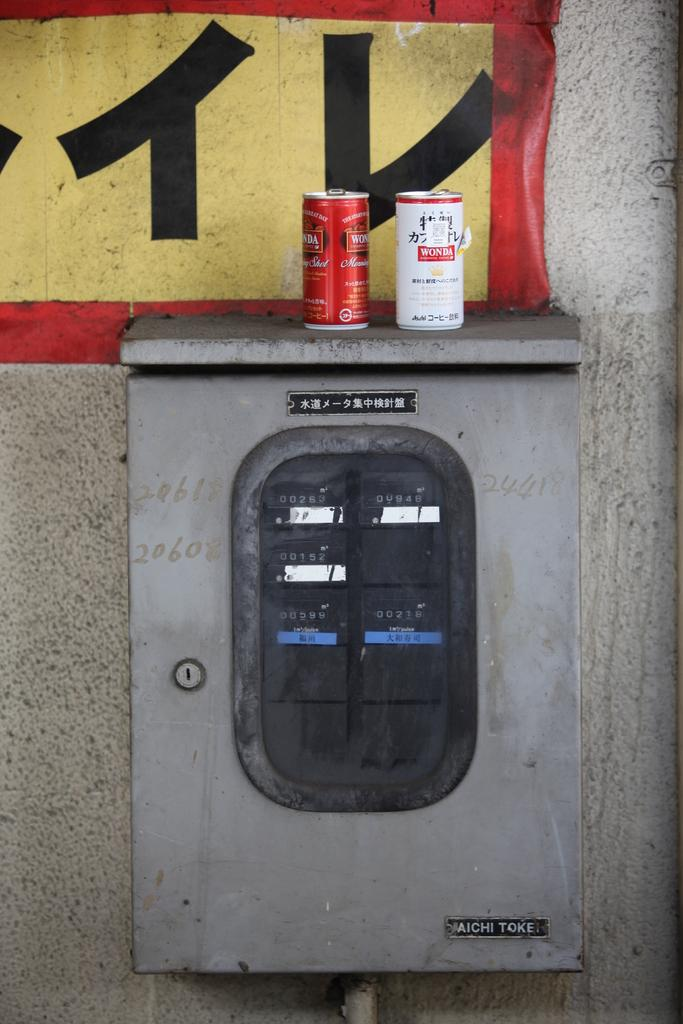<image>
Render a clear and concise summary of the photo. One red and one white, Wonda beverage cans are sitting on top of a grey, electrical box with Chinese letters on the front of it. 